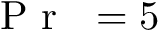<formula> <loc_0><loc_0><loc_500><loc_500>{ P r } = 5</formula> 